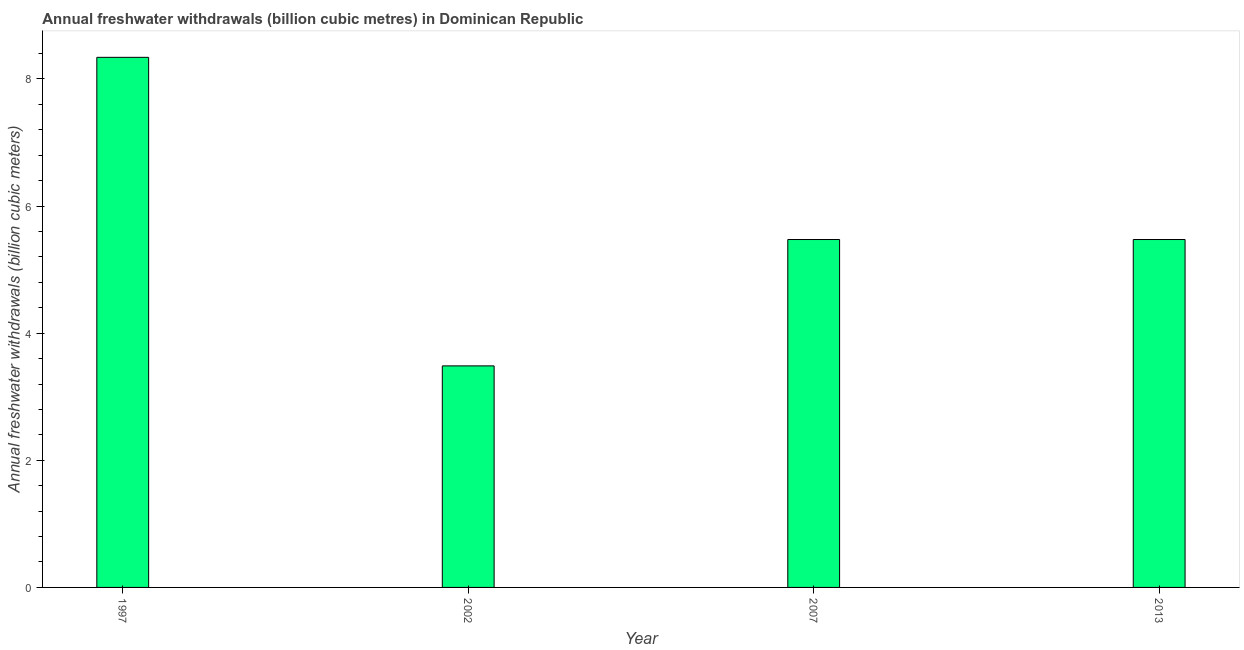What is the title of the graph?
Offer a terse response. Annual freshwater withdrawals (billion cubic metres) in Dominican Republic. What is the label or title of the X-axis?
Your answer should be compact. Year. What is the label or title of the Y-axis?
Give a very brief answer. Annual freshwater withdrawals (billion cubic meters). What is the annual freshwater withdrawals in 2013?
Your answer should be very brief. 5.47. Across all years, what is the maximum annual freshwater withdrawals?
Keep it short and to the point. 8.34. Across all years, what is the minimum annual freshwater withdrawals?
Offer a terse response. 3.48. In which year was the annual freshwater withdrawals minimum?
Provide a succinct answer. 2002. What is the sum of the annual freshwater withdrawals?
Provide a short and direct response. 22.77. What is the difference between the annual freshwater withdrawals in 2002 and 2007?
Your response must be concise. -1.99. What is the average annual freshwater withdrawals per year?
Make the answer very short. 5.69. What is the median annual freshwater withdrawals?
Your response must be concise. 5.47. Do a majority of the years between 2013 and 1997 (inclusive) have annual freshwater withdrawals greater than 0.4 billion cubic meters?
Your answer should be very brief. Yes. What is the ratio of the annual freshwater withdrawals in 1997 to that in 2007?
Keep it short and to the point. 1.52. Is the annual freshwater withdrawals in 2002 less than that in 2007?
Keep it short and to the point. Yes. What is the difference between the highest and the second highest annual freshwater withdrawals?
Ensure brevity in your answer.  2.87. What is the difference between the highest and the lowest annual freshwater withdrawals?
Ensure brevity in your answer.  4.85. How many bars are there?
Ensure brevity in your answer.  4. How many years are there in the graph?
Provide a succinct answer. 4. Are the values on the major ticks of Y-axis written in scientific E-notation?
Your answer should be very brief. No. What is the Annual freshwater withdrawals (billion cubic meters) of 1997?
Offer a very short reply. 8.34. What is the Annual freshwater withdrawals (billion cubic meters) in 2002?
Your answer should be compact. 3.48. What is the Annual freshwater withdrawals (billion cubic meters) of 2007?
Provide a succinct answer. 5.47. What is the Annual freshwater withdrawals (billion cubic meters) of 2013?
Offer a very short reply. 5.47. What is the difference between the Annual freshwater withdrawals (billion cubic meters) in 1997 and 2002?
Keep it short and to the point. 4.85. What is the difference between the Annual freshwater withdrawals (billion cubic meters) in 1997 and 2007?
Give a very brief answer. 2.87. What is the difference between the Annual freshwater withdrawals (billion cubic meters) in 1997 and 2013?
Your answer should be compact. 2.87. What is the difference between the Annual freshwater withdrawals (billion cubic meters) in 2002 and 2007?
Provide a succinct answer. -1.99. What is the difference between the Annual freshwater withdrawals (billion cubic meters) in 2002 and 2013?
Provide a short and direct response. -1.99. What is the ratio of the Annual freshwater withdrawals (billion cubic meters) in 1997 to that in 2002?
Provide a succinct answer. 2.39. What is the ratio of the Annual freshwater withdrawals (billion cubic meters) in 1997 to that in 2007?
Give a very brief answer. 1.52. What is the ratio of the Annual freshwater withdrawals (billion cubic meters) in 1997 to that in 2013?
Give a very brief answer. 1.52. What is the ratio of the Annual freshwater withdrawals (billion cubic meters) in 2002 to that in 2007?
Provide a short and direct response. 0.64. What is the ratio of the Annual freshwater withdrawals (billion cubic meters) in 2002 to that in 2013?
Give a very brief answer. 0.64. 